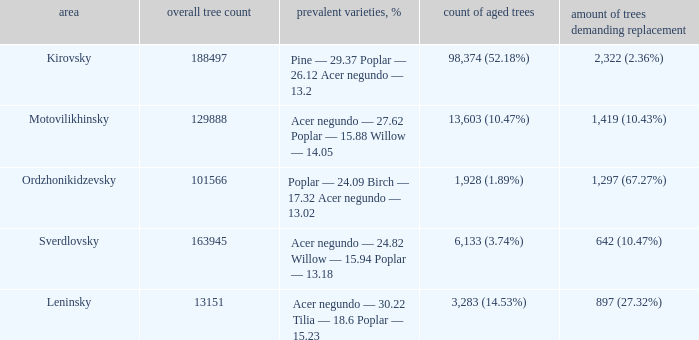What is the total amount of trees when district is leninsky? 13151.0. 